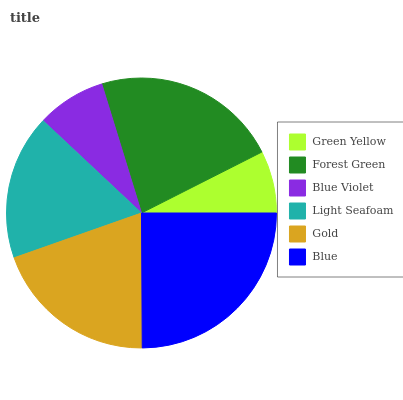Is Green Yellow the minimum?
Answer yes or no. Yes. Is Blue the maximum?
Answer yes or no. Yes. Is Forest Green the minimum?
Answer yes or no. No. Is Forest Green the maximum?
Answer yes or no. No. Is Forest Green greater than Green Yellow?
Answer yes or no. Yes. Is Green Yellow less than Forest Green?
Answer yes or no. Yes. Is Green Yellow greater than Forest Green?
Answer yes or no. No. Is Forest Green less than Green Yellow?
Answer yes or no. No. Is Gold the high median?
Answer yes or no. Yes. Is Light Seafoam the low median?
Answer yes or no. Yes. Is Light Seafoam the high median?
Answer yes or no. No. Is Green Yellow the low median?
Answer yes or no. No. 